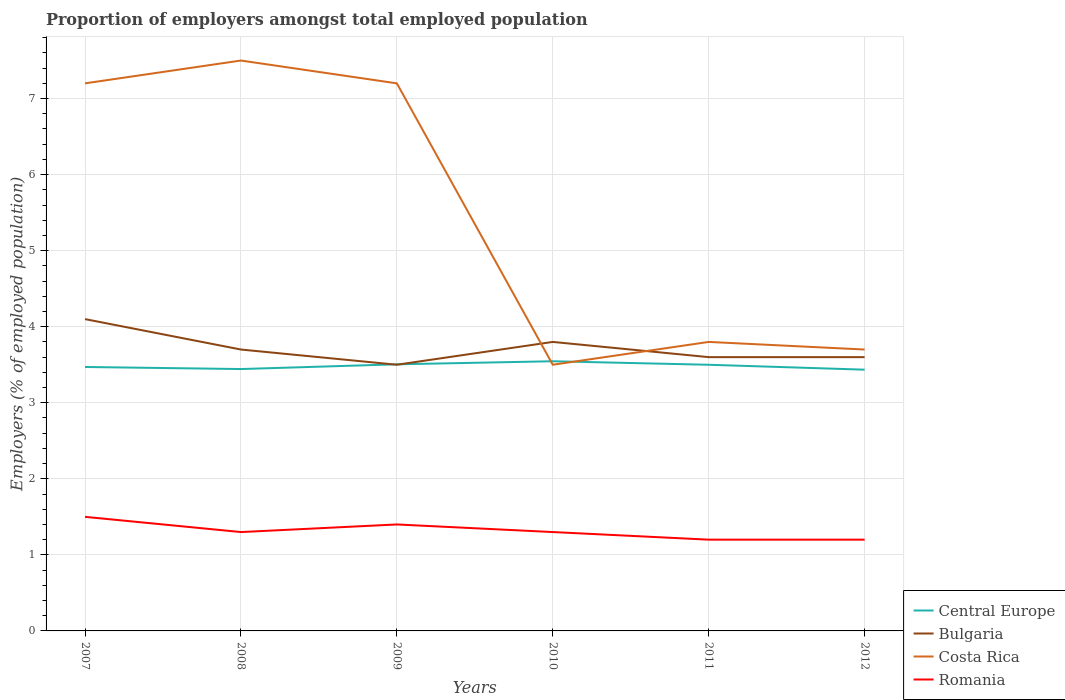Does the line corresponding to Bulgaria intersect with the line corresponding to Costa Rica?
Your response must be concise. Yes. Across all years, what is the maximum proportion of employers in Central Europe?
Ensure brevity in your answer.  3.44. What is the total proportion of employers in Costa Rica in the graph?
Your answer should be compact. 3.8. What is the difference between the highest and the second highest proportion of employers in Central Europe?
Provide a short and direct response. 0.11. What is the difference between the highest and the lowest proportion of employers in Bulgaria?
Give a very brief answer. 2. What is the difference between two consecutive major ticks on the Y-axis?
Offer a very short reply. 1. Are the values on the major ticks of Y-axis written in scientific E-notation?
Your response must be concise. No. What is the title of the graph?
Offer a terse response. Proportion of employers amongst total employed population. What is the label or title of the Y-axis?
Make the answer very short. Employers (% of employed population). What is the Employers (% of employed population) in Central Europe in 2007?
Give a very brief answer. 3.47. What is the Employers (% of employed population) in Bulgaria in 2007?
Keep it short and to the point. 4.1. What is the Employers (% of employed population) in Costa Rica in 2007?
Your answer should be compact. 7.2. What is the Employers (% of employed population) of Central Europe in 2008?
Ensure brevity in your answer.  3.44. What is the Employers (% of employed population) of Bulgaria in 2008?
Offer a very short reply. 3.7. What is the Employers (% of employed population) in Romania in 2008?
Offer a very short reply. 1.3. What is the Employers (% of employed population) of Central Europe in 2009?
Offer a very short reply. 3.51. What is the Employers (% of employed population) in Bulgaria in 2009?
Provide a short and direct response. 3.5. What is the Employers (% of employed population) in Costa Rica in 2009?
Provide a short and direct response. 7.2. What is the Employers (% of employed population) in Romania in 2009?
Ensure brevity in your answer.  1.4. What is the Employers (% of employed population) in Central Europe in 2010?
Provide a short and direct response. 3.55. What is the Employers (% of employed population) in Bulgaria in 2010?
Offer a very short reply. 3.8. What is the Employers (% of employed population) of Romania in 2010?
Your answer should be very brief. 1.3. What is the Employers (% of employed population) of Central Europe in 2011?
Provide a short and direct response. 3.5. What is the Employers (% of employed population) of Bulgaria in 2011?
Keep it short and to the point. 3.6. What is the Employers (% of employed population) of Costa Rica in 2011?
Give a very brief answer. 3.8. What is the Employers (% of employed population) of Romania in 2011?
Offer a terse response. 1.2. What is the Employers (% of employed population) of Central Europe in 2012?
Your response must be concise. 3.44. What is the Employers (% of employed population) in Bulgaria in 2012?
Offer a very short reply. 3.6. What is the Employers (% of employed population) of Costa Rica in 2012?
Offer a terse response. 3.7. What is the Employers (% of employed population) of Romania in 2012?
Offer a terse response. 1.2. Across all years, what is the maximum Employers (% of employed population) of Central Europe?
Your response must be concise. 3.55. Across all years, what is the maximum Employers (% of employed population) in Bulgaria?
Your response must be concise. 4.1. Across all years, what is the minimum Employers (% of employed population) of Central Europe?
Offer a very short reply. 3.44. Across all years, what is the minimum Employers (% of employed population) of Bulgaria?
Provide a short and direct response. 3.5. Across all years, what is the minimum Employers (% of employed population) of Romania?
Offer a terse response. 1.2. What is the total Employers (% of employed population) in Central Europe in the graph?
Your answer should be very brief. 20.9. What is the total Employers (% of employed population) in Bulgaria in the graph?
Ensure brevity in your answer.  22.3. What is the total Employers (% of employed population) in Costa Rica in the graph?
Give a very brief answer. 32.9. What is the difference between the Employers (% of employed population) in Central Europe in 2007 and that in 2008?
Ensure brevity in your answer.  0.03. What is the difference between the Employers (% of employed population) in Bulgaria in 2007 and that in 2008?
Your response must be concise. 0.4. What is the difference between the Employers (% of employed population) in Costa Rica in 2007 and that in 2008?
Provide a succinct answer. -0.3. What is the difference between the Employers (% of employed population) of Romania in 2007 and that in 2008?
Ensure brevity in your answer.  0.2. What is the difference between the Employers (% of employed population) of Central Europe in 2007 and that in 2009?
Provide a succinct answer. -0.04. What is the difference between the Employers (% of employed population) of Central Europe in 2007 and that in 2010?
Your answer should be compact. -0.08. What is the difference between the Employers (% of employed population) of Costa Rica in 2007 and that in 2010?
Keep it short and to the point. 3.7. What is the difference between the Employers (% of employed population) of Central Europe in 2007 and that in 2011?
Your answer should be very brief. -0.03. What is the difference between the Employers (% of employed population) in Costa Rica in 2007 and that in 2011?
Provide a short and direct response. 3.4. What is the difference between the Employers (% of employed population) in Romania in 2007 and that in 2011?
Ensure brevity in your answer.  0.3. What is the difference between the Employers (% of employed population) in Central Europe in 2007 and that in 2012?
Your answer should be very brief. 0.04. What is the difference between the Employers (% of employed population) of Central Europe in 2008 and that in 2009?
Your answer should be very brief. -0.06. What is the difference between the Employers (% of employed population) of Bulgaria in 2008 and that in 2009?
Make the answer very short. 0.2. What is the difference between the Employers (% of employed population) of Costa Rica in 2008 and that in 2009?
Offer a terse response. 0.3. What is the difference between the Employers (% of employed population) of Romania in 2008 and that in 2009?
Provide a succinct answer. -0.1. What is the difference between the Employers (% of employed population) of Central Europe in 2008 and that in 2010?
Keep it short and to the point. -0.1. What is the difference between the Employers (% of employed population) in Bulgaria in 2008 and that in 2010?
Provide a short and direct response. -0.1. What is the difference between the Employers (% of employed population) in Costa Rica in 2008 and that in 2010?
Give a very brief answer. 4. What is the difference between the Employers (% of employed population) in Romania in 2008 and that in 2010?
Give a very brief answer. 0. What is the difference between the Employers (% of employed population) of Central Europe in 2008 and that in 2011?
Provide a short and direct response. -0.06. What is the difference between the Employers (% of employed population) of Bulgaria in 2008 and that in 2011?
Provide a short and direct response. 0.1. What is the difference between the Employers (% of employed population) of Costa Rica in 2008 and that in 2011?
Offer a very short reply. 3.7. What is the difference between the Employers (% of employed population) of Central Europe in 2008 and that in 2012?
Your answer should be very brief. 0.01. What is the difference between the Employers (% of employed population) in Bulgaria in 2008 and that in 2012?
Keep it short and to the point. 0.1. What is the difference between the Employers (% of employed population) of Romania in 2008 and that in 2012?
Provide a short and direct response. 0.1. What is the difference between the Employers (% of employed population) of Central Europe in 2009 and that in 2010?
Give a very brief answer. -0.04. What is the difference between the Employers (% of employed population) in Bulgaria in 2009 and that in 2010?
Provide a short and direct response. -0.3. What is the difference between the Employers (% of employed population) of Costa Rica in 2009 and that in 2010?
Provide a succinct answer. 3.7. What is the difference between the Employers (% of employed population) of Romania in 2009 and that in 2010?
Your response must be concise. 0.1. What is the difference between the Employers (% of employed population) in Central Europe in 2009 and that in 2011?
Your answer should be compact. 0.01. What is the difference between the Employers (% of employed population) in Costa Rica in 2009 and that in 2011?
Ensure brevity in your answer.  3.4. What is the difference between the Employers (% of employed population) in Central Europe in 2009 and that in 2012?
Offer a terse response. 0.07. What is the difference between the Employers (% of employed population) of Bulgaria in 2009 and that in 2012?
Your response must be concise. -0.1. What is the difference between the Employers (% of employed population) in Central Europe in 2010 and that in 2011?
Provide a succinct answer. 0.05. What is the difference between the Employers (% of employed population) in Bulgaria in 2010 and that in 2011?
Ensure brevity in your answer.  0.2. What is the difference between the Employers (% of employed population) in Central Europe in 2010 and that in 2012?
Offer a very short reply. 0.11. What is the difference between the Employers (% of employed population) of Central Europe in 2011 and that in 2012?
Make the answer very short. 0.06. What is the difference between the Employers (% of employed population) in Bulgaria in 2011 and that in 2012?
Give a very brief answer. 0. What is the difference between the Employers (% of employed population) of Costa Rica in 2011 and that in 2012?
Make the answer very short. 0.1. What is the difference between the Employers (% of employed population) in Central Europe in 2007 and the Employers (% of employed population) in Bulgaria in 2008?
Offer a very short reply. -0.23. What is the difference between the Employers (% of employed population) in Central Europe in 2007 and the Employers (% of employed population) in Costa Rica in 2008?
Your answer should be very brief. -4.03. What is the difference between the Employers (% of employed population) in Central Europe in 2007 and the Employers (% of employed population) in Romania in 2008?
Provide a short and direct response. 2.17. What is the difference between the Employers (% of employed population) in Bulgaria in 2007 and the Employers (% of employed population) in Costa Rica in 2008?
Give a very brief answer. -3.4. What is the difference between the Employers (% of employed population) in Costa Rica in 2007 and the Employers (% of employed population) in Romania in 2008?
Your answer should be very brief. 5.9. What is the difference between the Employers (% of employed population) of Central Europe in 2007 and the Employers (% of employed population) of Bulgaria in 2009?
Keep it short and to the point. -0.03. What is the difference between the Employers (% of employed population) of Central Europe in 2007 and the Employers (% of employed population) of Costa Rica in 2009?
Provide a short and direct response. -3.73. What is the difference between the Employers (% of employed population) of Central Europe in 2007 and the Employers (% of employed population) of Romania in 2009?
Offer a terse response. 2.07. What is the difference between the Employers (% of employed population) of Bulgaria in 2007 and the Employers (% of employed population) of Costa Rica in 2009?
Offer a very short reply. -3.1. What is the difference between the Employers (% of employed population) of Bulgaria in 2007 and the Employers (% of employed population) of Romania in 2009?
Provide a succinct answer. 2.7. What is the difference between the Employers (% of employed population) in Costa Rica in 2007 and the Employers (% of employed population) in Romania in 2009?
Provide a short and direct response. 5.8. What is the difference between the Employers (% of employed population) of Central Europe in 2007 and the Employers (% of employed population) of Bulgaria in 2010?
Keep it short and to the point. -0.33. What is the difference between the Employers (% of employed population) in Central Europe in 2007 and the Employers (% of employed population) in Costa Rica in 2010?
Offer a very short reply. -0.03. What is the difference between the Employers (% of employed population) of Central Europe in 2007 and the Employers (% of employed population) of Romania in 2010?
Make the answer very short. 2.17. What is the difference between the Employers (% of employed population) in Bulgaria in 2007 and the Employers (% of employed population) in Romania in 2010?
Offer a very short reply. 2.8. What is the difference between the Employers (% of employed population) in Costa Rica in 2007 and the Employers (% of employed population) in Romania in 2010?
Your answer should be compact. 5.9. What is the difference between the Employers (% of employed population) of Central Europe in 2007 and the Employers (% of employed population) of Bulgaria in 2011?
Make the answer very short. -0.13. What is the difference between the Employers (% of employed population) of Central Europe in 2007 and the Employers (% of employed population) of Costa Rica in 2011?
Your response must be concise. -0.33. What is the difference between the Employers (% of employed population) in Central Europe in 2007 and the Employers (% of employed population) in Romania in 2011?
Ensure brevity in your answer.  2.27. What is the difference between the Employers (% of employed population) of Bulgaria in 2007 and the Employers (% of employed population) of Costa Rica in 2011?
Give a very brief answer. 0.3. What is the difference between the Employers (% of employed population) of Bulgaria in 2007 and the Employers (% of employed population) of Romania in 2011?
Provide a short and direct response. 2.9. What is the difference between the Employers (% of employed population) of Central Europe in 2007 and the Employers (% of employed population) of Bulgaria in 2012?
Your answer should be very brief. -0.13. What is the difference between the Employers (% of employed population) of Central Europe in 2007 and the Employers (% of employed population) of Costa Rica in 2012?
Keep it short and to the point. -0.23. What is the difference between the Employers (% of employed population) in Central Europe in 2007 and the Employers (% of employed population) in Romania in 2012?
Make the answer very short. 2.27. What is the difference between the Employers (% of employed population) in Bulgaria in 2007 and the Employers (% of employed population) in Costa Rica in 2012?
Your answer should be compact. 0.4. What is the difference between the Employers (% of employed population) in Costa Rica in 2007 and the Employers (% of employed population) in Romania in 2012?
Keep it short and to the point. 6. What is the difference between the Employers (% of employed population) in Central Europe in 2008 and the Employers (% of employed population) in Bulgaria in 2009?
Your response must be concise. -0.06. What is the difference between the Employers (% of employed population) in Central Europe in 2008 and the Employers (% of employed population) in Costa Rica in 2009?
Your answer should be very brief. -3.76. What is the difference between the Employers (% of employed population) in Central Europe in 2008 and the Employers (% of employed population) in Romania in 2009?
Give a very brief answer. 2.04. What is the difference between the Employers (% of employed population) of Bulgaria in 2008 and the Employers (% of employed population) of Costa Rica in 2009?
Make the answer very short. -3.5. What is the difference between the Employers (% of employed population) in Central Europe in 2008 and the Employers (% of employed population) in Bulgaria in 2010?
Your answer should be very brief. -0.36. What is the difference between the Employers (% of employed population) in Central Europe in 2008 and the Employers (% of employed population) in Costa Rica in 2010?
Keep it short and to the point. -0.06. What is the difference between the Employers (% of employed population) in Central Europe in 2008 and the Employers (% of employed population) in Romania in 2010?
Give a very brief answer. 2.14. What is the difference between the Employers (% of employed population) in Bulgaria in 2008 and the Employers (% of employed population) in Costa Rica in 2010?
Provide a succinct answer. 0.2. What is the difference between the Employers (% of employed population) of Central Europe in 2008 and the Employers (% of employed population) of Bulgaria in 2011?
Give a very brief answer. -0.16. What is the difference between the Employers (% of employed population) of Central Europe in 2008 and the Employers (% of employed population) of Costa Rica in 2011?
Make the answer very short. -0.36. What is the difference between the Employers (% of employed population) of Central Europe in 2008 and the Employers (% of employed population) of Romania in 2011?
Give a very brief answer. 2.24. What is the difference between the Employers (% of employed population) in Bulgaria in 2008 and the Employers (% of employed population) in Romania in 2011?
Your response must be concise. 2.5. What is the difference between the Employers (% of employed population) in Costa Rica in 2008 and the Employers (% of employed population) in Romania in 2011?
Keep it short and to the point. 6.3. What is the difference between the Employers (% of employed population) in Central Europe in 2008 and the Employers (% of employed population) in Bulgaria in 2012?
Your answer should be compact. -0.16. What is the difference between the Employers (% of employed population) of Central Europe in 2008 and the Employers (% of employed population) of Costa Rica in 2012?
Your answer should be very brief. -0.26. What is the difference between the Employers (% of employed population) in Central Europe in 2008 and the Employers (% of employed population) in Romania in 2012?
Your answer should be compact. 2.24. What is the difference between the Employers (% of employed population) of Bulgaria in 2008 and the Employers (% of employed population) of Costa Rica in 2012?
Make the answer very short. 0. What is the difference between the Employers (% of employed population) of Central Europe in 2009 and the Employers (% of employed population) of Bulgaria in 2010?
Offer a terse response. -0.29. What is the difference between the Employers (% of employed population) of Central Europe in 2009 and the Employers (% of employed population) of Costa Rica in 2010?
Your response must be concise. 0.01. What is the difference between the Employers (% of employed population) in Central Europe in 2009 and the Employers (% of employed population) in Romania in 2010?
Make the answer very short. 2.21. What is the difference between the Employers (% of employed population) in Bulgaria in 2009 and the Employers (% of employed population) in Romania in 2010?
Your response must be concise. 2.2. What is the difference between the Employers (% of employed population) in Central Europe in 2009 and the Employers (% of employed population) in Bulgaria in 2011?
Ensure brevity in your answer.  -0.09. What is the difference between the Employers (% of employed population) in Central Europe in 2009 and the Employers (% of employed population) in Costa Rica in 2011?
Provide a short and direct response. -0.29. What is the difference between the Employers (% of employed population) in Central Europe in 2009 and the Employers (% of employed population) in Romania in 2011?
Your response must be concise. 2.31. What is the difference between the Employers (% of employed population) of Bulgaria in 2009 and the Employers (% of employed population) of Romania in 2011?
Give a very brief answer. 2.3. What is the difference between the Employers (% of employed population) in Central Europe in 2009 and the Employers (% of employed population) in Bulgaria in 2012?
Offer a terse response. -0.09. What is the difference between the Employers (% of employed population) of Central Europe in 2009 and the Employers (% of employed population) of Costa Rica in 2012?
Your response must be concise. -0.19. What is the difference between the Employers (% of employed population) in Central Europe in 2009 and the Employers (% of employed population) in Romania in 2012?
Your response must be concise. 2.31. What is the difference between the Employers (% of employed population) of Bulgaria in 2009 and the Employers (% of employed population) of Costa Rica in 2012?
Provide a short and direct response. -0.2. What is the difference between the Employers (% of employed population) in Costa Rica in 2009 and the Employers (% of employed population) in Romania in 2012?
Make the answer very short. 6. What is the difference between the Employers (% of employed population) of Central Europe in 2010 and the Employers (% of employed population) of Bulgaria in 2011?
Make the answer very short. -0.05. What is the difference between the Employers (% of employed population) of Central Europe in 2010 and the Employers (% of employed population) of Costa Rica in 2011?
Keep it short and to the point. -0.25. What is the difference between the Employers (% of employed population) in Central Europe in 2010 and the Employers (% of employed population) in Romania in 2011?
Ensure brevity in your answer.  2.35. What is the difference between the Employers (% of employed population) in Bulgaria in 2010 and the Employers (% of employed population) in Romania in 2011?
Provide a succinct answer. 2.6. What is the difference between the Employers (% of employed population) of Costa Rica in 2010 and the Employers (% of employed population) of Romania in 2011?
Provide a short and direct response. 2.3. What is the difference between the Employers (% of employed population) in Central Europe in 2010 and the Employers (% of employed population) in Bulgaria in 2012?
Your answer should be very brief. -0.05. What is the difference between the Employers (% of employed population) of Central Europe in 2010 and the Employers (% of employed population) of Costa Rica in 2012?
Provide a short and direct response. -0.15. What is the difference between the Employers (% of employed population) in Central Europe in 2010 and the Employers (% of employed population) in Romania in 2012?
Your answer should be very brief. 2.35. What is the difference between the Employers (% of employed population) of Bulgaria in 2010 and the Employers (% of employed population) of Costa Rica in 2012?
Provide a succinct answer. 0.1. What is the difference between the Employers (% of employed population) of Bulgaria in 2010 and the Employers (% of employed population) of Romania in 2012?
Your answer should be compact. 2.6. What is the difference between the Employers (% of employed population) of Central Europe in 2011 and the Employers (% of employed population) of Bulgaria in 2012?
Your response must be concise. -0.1. What is the difference between the Employers (% of employed population) in Central Europe in 2011 and the Employers (% of employed population) in Costa Rica in 2012?
Offer a terse response. -0.2. What is the difference between the Employers (% of employed population) of Central Europe in 2011 and the Employers (% of employed population) of Romania in 2012?
Provide a succinct answer. 2.3. What is the difference between the Employers (% of employed population) in Bulgaria in 2011 and the Employers (% of employed population) in Costa Rica in 2012?
Your answer should be compact. -0.1. What is the difference between the Employers (% of employed population) in Costa Rica in 2011 and the Employers (% of employed population) in Romania in 2012?
Provide a succinct answer. 2.6. What is the average Employers (% of employed population) of Central Europe per year?
Keep it short and to the point. 3.48. What is the average Employers (% of employed population) of Bulgaria per year?
Provide a succinct answer. 3.72. What is the average Employers (% of employed population) in Costa Rica per year?
Give a very brief answer. 5.48. What is the average Employers (% of employed population) of Romania per year?
Provide a succinct answer. 1.32. In the year 2007, what is the difference between the Employers (% of employed population) in Central Europe and Employers (% of employed population) in Bulgaria?
Offer a terse response. -0.63. In the year 2007, what is the difference between the Employers (% of employed population) in Central Europe and Employers (% of employed population) in Costa Rica?
Your response must be concise. -3.73. In the year 2007, what is the difference between the Employers (% of employed population) of Central Europe and Employers (% of employed population) of Romania?
Your response must be concise. 1.97. In the year 2007, what is the difference between the Employers (% of employed population) in Bulgaria and Employers (% of employed population) in Costa Rica?
Your answer should be compact. -3.1. In the year 2007, what is the difference between the Employers (% of employed population) in Bulgaria and Employers (% of employed population) in Romania?
Keep it short and to the point. 2.6. In the year 2007, what is the difference between the Employers (% of employed population) of Costa Rica and Employers (% of employed population) of Romania?
Give a very brief answer. 5.7. In the year 2008, what is the difference between the Employers (% of employed population) in Central Europe and Employers (% of employed population) in Bulgaria?
Ensure brevity in your answer.  -0.26. In the year 2008, what is the difference between the Employers (% of employed population) of Central Europe and Employers (% of employed population) of Costa Rica?
Your answer should be very brief. -4.06. In the year 2008, what is the difference between the Employers (% of employed population) in Central Europe and Employers (% of employed population) in Romania?
Offer a very short reply. 2.14. In the year 2008, what is the difference between the Employers (% of employed population) in Bulgaria and Employers (% of employed population) in Costa Rica?
Make the answer very short. -3.8. In the year 2008, what is the difference between the Employers (% of employed population) of Costa Rica and Employers (% of employed population) of Romania?
Offer a very short reply. 6.2. In the year 2009, what is the difference between the Employers (% of employed population) of Central Europe and Employers (% of employed population) of Bulgaria?
Keep it short and to the point. 0.01. In the year 2009, what is the difference between the Employers (% of employed population) in Central Europe and Employers (% of employed population) in Costa Rica?
Your answer should be compact. -3.69. In the year 2009, what is the difference between the Employers (% of employed population) of Central Europe and Employers (% of employed population) of Romania?
Give a very brief answer. 2.11. In the year 2009, what is the difference between the Employers (% of employed population) in Bulgaria and Employers (% of employed population) in Costa Rica?
Keep it short and to the point. -3.7. In the year 2009, what is the difference between the Employers (% of employed population) of Bulgaria and Employers (% of employed population) of Romania?
Give a very brief answer. 2.1. In the year 2009, what is the difference between the Employers (% of employed population) of Costa Rica and Employers (% of employed population) of Romania?
Your response must be concise. 5.8. In the year 2010, what is the difference between the Employers (% of employed population) of Central Europe and Employers (% of employed population) of Bulgaria?
Offer a very short reply. -0.25. In the year 2010, what is the difference between the Employers (% of employed population) in Central Europe and Employers (% of employed population) in Costa Rica?
Offer a very short reply. 0.05. In the year 2010, what is the difference between the Employers (% of employed population) in Central Europe and Employers (% of employed population) in Romania?
Give a very brief answer. 2.25. In the year 2011, what is the difference between the Employers (% of employed population) in Central Europe and Employers (% of employed population) in Bulgaria?
Your answer should be very brief. -0.1. In the year 2011, what is the difference between the Employers (% of employed population) in Central Europe and Employers (% of employed population) in Costa Rica?
Ensure brevity in your answer.  -0.3. In the year 2011, what is the difference between the Employers (% of employed population) of Central Europe and Employers (% of employed population) of Romania?
Provide a short and direct response. 2.3. In the year 2011, what is the difference between the Employers (% of employed population) of Bulgaria and Employers (% of employed population) of Romania?
Give a very brief answer. 2.4. In the year 2012, what is the difference between the Employers (% of employed population) in Central Europe and Employers (% of employed population) in Bulgaria?
Offer a very short reply. -0.16. In the year 2012, what is the difference between the Employers (% of employed population) in Central Europe and Employers (% of employed population) in Costa Rica?
Your answer should be very brief. -0.26. In the year 2012, what is the difference between the Employers (% of employed population) of Central Europe and Employers (% of employed population) of Romania?
Your response must be concise. 2.24. In the year 2012, what is the difference between the Employers (% of employed population) in Bulgaria and Employers (% of employed population) in Romania?
Ensure brevity in your answer.  2.4. In the year 2012, what is the difference between the Employers (% of employed population) in Costa Rica and Employers (% of employed population) in Romania?
Provide a short and direct response. 2.5. What is the ratio of the Employers (% of employed population) in Central Europe in 2007 to that in 2008?
Provide a succinct answer. 1.01. What is the ratio of the Employers (% of employed population) in Bulgaria in 2007 to that in 2008?
Your answer should be compact. 1.11. What is the ratio of the Employers (% of employed population) in Romania in 2007 to that in 2008?
Keep it short and to the point. 1.15. What is the ratio of the Employers (% of employed population) of Central Europe in 2007 to that in 2009?
Ensure brevity in your answer.  0.99. What is the ratio of the Employers (% of employed population) of Bulgaria in 2007 to that in 2009?
Keep it short and to the point. 1.17. What is the ratio of the Employers (% of employed population) in Romania in 2007 to that in 2009?
Give a very brief answer. 1.07. What is the ratio of the Employers (% of employed population) in Central Europe in 2007 to that in 2010?
Provide a short and direct response. 0.98. What is the ratio of the Employers (% of employed population) of Bulgaria in 2007 to that in 2010?
Your response must be concise. 1.08. What is the ratio of the Employers (% of employed population) in Costa Rica in 2007 to that in 2010?
Your answer should be very brief. 2.06. What is the ratio of the Employers (% of employed population) in Romania in 2007 to that in 2010?
Give a very brief answer. 1.15. What is the ratio of the Employers (% of employed population) of Central Europe in 2007 to that in 2011?
Ensure brevity in your answer.  0.99. What is the ratio of the Employers (% of employed population) of Bulgaria in 2007 to that in 2011?
Ensure brevity in your answer.  1.14. What is the ratio of the Employers (% of employed population) in Costa Rica in 2007 to that in 2011?
Your response must be concise. 1.89. What is the ratio of the Employers (% of employed population) in Romania in 2007 to that in 2011?
Make the answer very short. 1.25. What is the ratio of the Employers (% of employed population) in Central Europe in 2007 to that in 2012?
Provide a short and direct response. 1.01. What is the ratio of the Employers (% of employed population) of Bulgaria in 2007 to that in 2012?
Give a very brief answer. 1.14. What is the ratio of the Employers (% of employed population) in Costa Rica in 2007 to that in 2012?
Provide a short and direct response. 1.95. What is the ratio of the Employers (% of employed population) of Central Europe in 2008 to that in 2009?
Offer a terse response. 0.98. What is the ratio of the Employers (% of employed population) of Bulgaria in 2008 to that in 2009?
Your answer should be compact. 1.06. What is the ratio of the Employers (% of employed population) of Costa Rica in 2008 to that in 2009?
Offer a very short reply. 1.04. What is the ratio of the Employers (% of employed population) of Central Europe in 2008 to that in 2010?
Provide a succinct answer. 0.97. What is the ratio of the Employers (% of employed population) in Bulgaria in 2008 to that in 2010?
Offer a terse response. 0.97. What is the ratio of the Employers (% of employed population) in Costa Rica in 2008 to that in 2010?
Provide a succinct answer. 2.14. What is the ratio of the Employers (% of employed population) in Romania in 2008 to that in 2010?
Keep it short and to the point. 1. What is the ratio of the Employers (% of employed population) in Central Europe in 2008 to that in 2011?
Make the answer very short. 0.98. What is the ratio of the Employers (% of employed population) in Bulgaria in 2008 to that in 2011?
Offer a terse response. 1.03. What is the ratio of the Employers (% of employed population) of Costa Rica in 2008 to that in 2011?
Ensure brevity in your answer.  1.97. What is the ratio of the Employers (% of employed population) in Romania in 2008 to that in 2011?
Keep it short and to the point. 1.08. What is the ratio of the Employers (% of employed population) of Bulgaria in 2008 to that in 2012?
Your answer should be compact. 1.03. What is the ratio of the Employers (% of employed population) of Costa Rica in 2008 to that in 2012?
Your answer should be compact. 2.03. What is the ratio of the Employers (% of employed population) in Romania in 2008 to that in 2012?
Your answer should be very brief. 1.08. What is the ratio of the Employers (% of employed population) in Central Europe in 2009 to that in 2010?
Ensure brevity in your answer.  0.99. What is the ratio of the Employers (% of employed population) of Bulgaria in 2009 to that in 2010?
Ensure brevity in your answer.  0.92. What is the ratio of the Employers (% of employed population) of Costa Rica in 2009 to that in 2010?
Your answer should be very brief. 2.06. What is the ratio of the Employers (% of employed population) of Romania in 2009 to that in 2010?
Offer a very short reply. 1.08. What is the ratio of the Employers (% of employed population) of Central Europe in 2009 to that in 2011?
Offer a terse response. 1. What is the ratio of the Employers (% of employed population) of Bulgaria in 2009 to that in 2011?
Offer a very short reply. 0.97. What is the ratio of the Employers (% of employed population) of Costa Rica in 2009 to that in 2011?
Your response must be concise. 1.89. What is the ratio of the Employers (% of employed population) in Central Europe in 2009 to that in 2012?
Your answer should be compact. 1.02. What is the ratio of the Employers (% of employed population) of Bulgaria in 2009 to that in 2012?
Offer a very short reply. 0.97. What is the ratio of the Employers (% of employed population) in Costa Rica in 2009 to that in 2012?
Give a very brief answer. 1.95. What is the ratio of the Employers (% of employed population) of Central Europe in 2010 to that in 2011?
Offer a terse response. 1.01. What is the ratio of the Employers (% of employed population) of Bulgaria in 2010 to that in 2011?
Offer a terse response. 1.06. What is the ratio of the Employers (% of employed population) of Costa Rica in 2010 to that in 2011?
Your answer should be very brief. 0.92. What is the ratio of the Employers (% of employed population) of Central Europe in 2010 to that in 2012?
Your answer should be compact. 1.03. What is the ratio of the Employers (% of employed population) in Bulgaria in 2010 to that in 2012?
Your answer should be compact. 1.06. What is the ratio of the Employers (% of employed population) in Costa Rica in 2010 to that in 2012?
Your answer should be compact. 0.95. What is the ratio of the Employers (% of employed population) of Central Europe in 2011 to that in 2012?
Offer a terse response. 1.02. What is the ratio of the Employers (% of employed population) of Bulgaria in 2011 to that in 2012?
Your response must be concise. 1. What is the ratio of the Employers (% of employed population) in Romania in 2011 to that in 2012?
Your answer should be compact. 1. What is the difference between the highest and the second highest Employers (% of employed population) in Central Europe?
Provide a succinct answer. 0.04. What is the difference between the highest and the second highest Employers (% of employed population) in Bulgaria?
Ensure brevity in your answer.  0.3. What is the difference between the highest and the second highest Employers (% of employed population) of Costa Rica?
Make the answer very short. 0.3. What is the difference between the highest and the lowest Employers (% of employed population) in Central Europe?
Provide a short and direct response. 0.11. What is the difference between the highest and the lowest Employers (% of employed population) of Bulgaria?
Provide a succinct answer. 0.6. What is the difference between the highest and the lowest Employers (% of employed population) in Romania?
Your response must be concise. 0.3. 